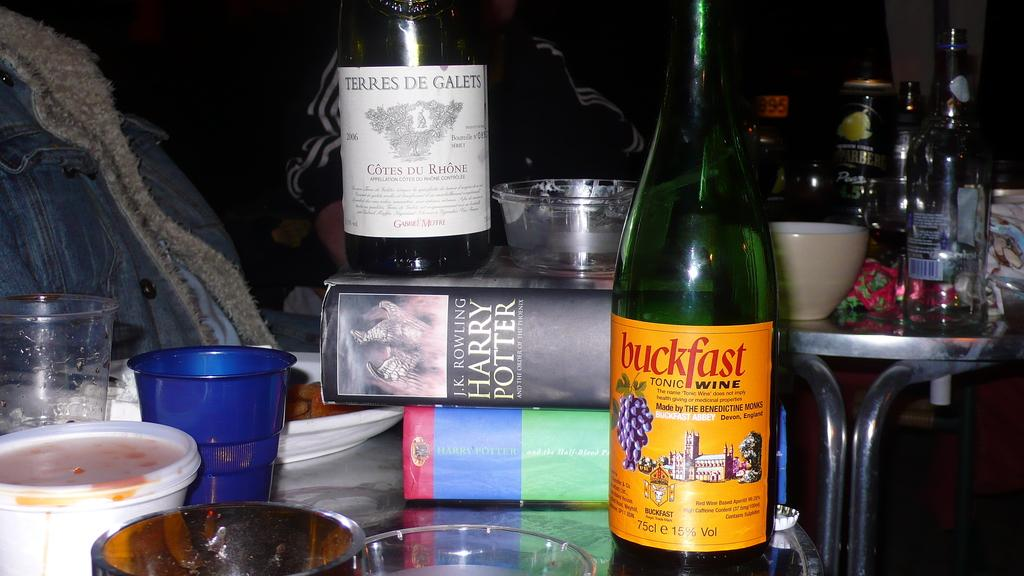<image>
Share a concise interpretation of the image provided. A Harry Potter book that is laying on its side 